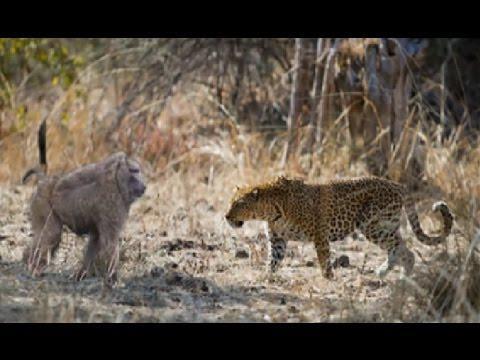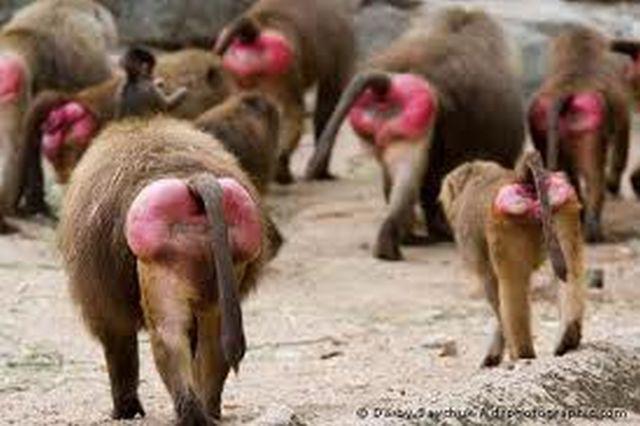The first image is the image on the left, the second image is the image on the right. For the images shown, is this caption "There are no felines in the images." true? Answer yes or no. No. 